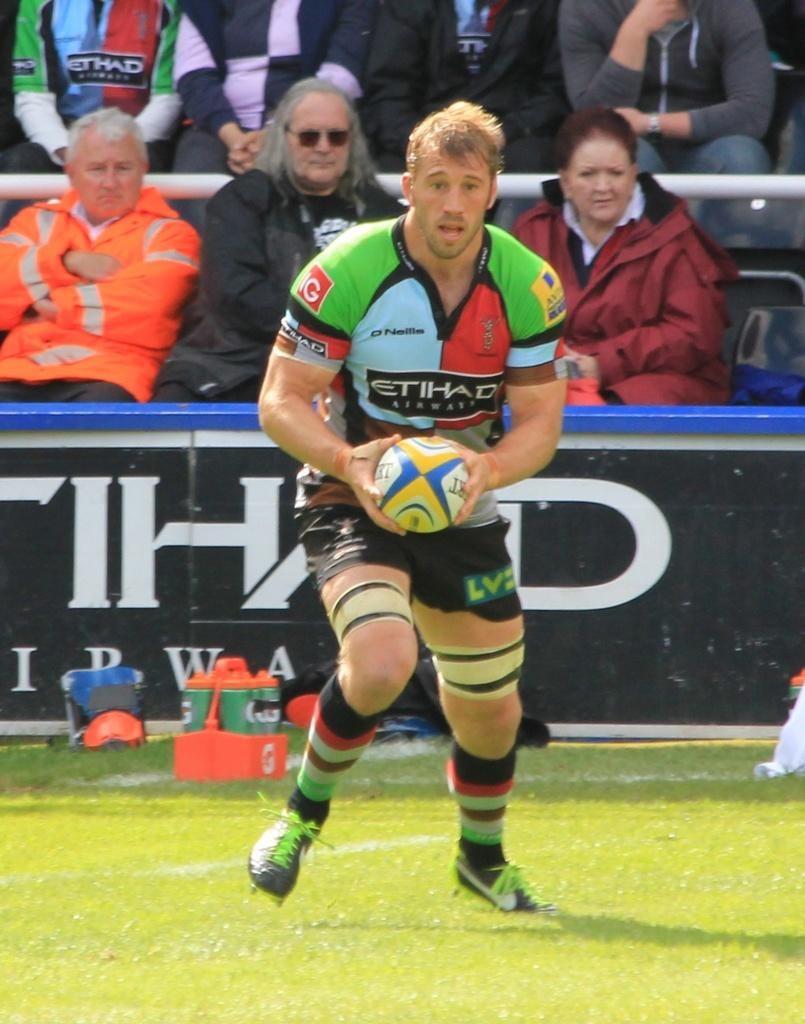What is the man in the image doing? The man is playing a game in the image. What is the man wearing while playing the game? The man is wearing a jersey in the image. What is the ground surface like in the image? There is green grass at the bottom of the image. What can be seen in the background of the image? There are people sitting in chairs in the background of the image. Can you hear the man crying while playing the game in the image? There is no indication of the man crying in the image, as it only shows him playing a game. What type of arm is visible in the image? There is no specific arm mentioned or visible in the image; it simply shows a man playing a game. 